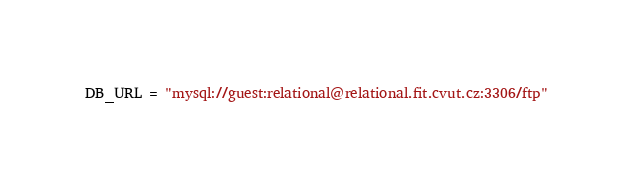Convert code to text. <code><loc_0><loc_0><loc_500><loc_500><_Python_>DB_URL = "mysql://guest:relational@relational.fit.cvut.cz:3306/ftp"
</code> 